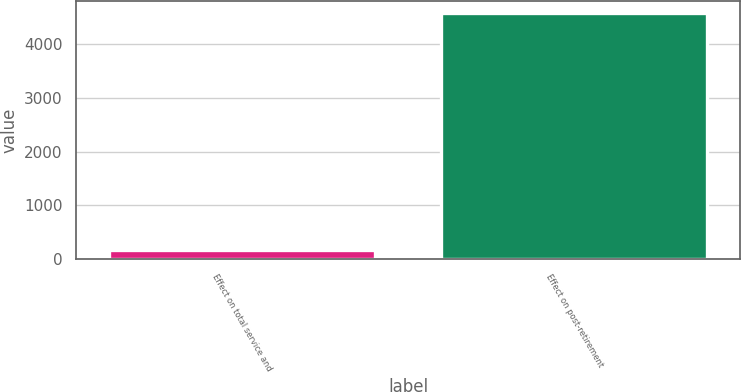Convert chart. <chart><loc_0><loc_0><loc_500><loc_500><bar_chart><fcel>Effect on total service and<fcel>Effect on post-retirement<nl><fcel>164<fcel>4567<nl></chart> 